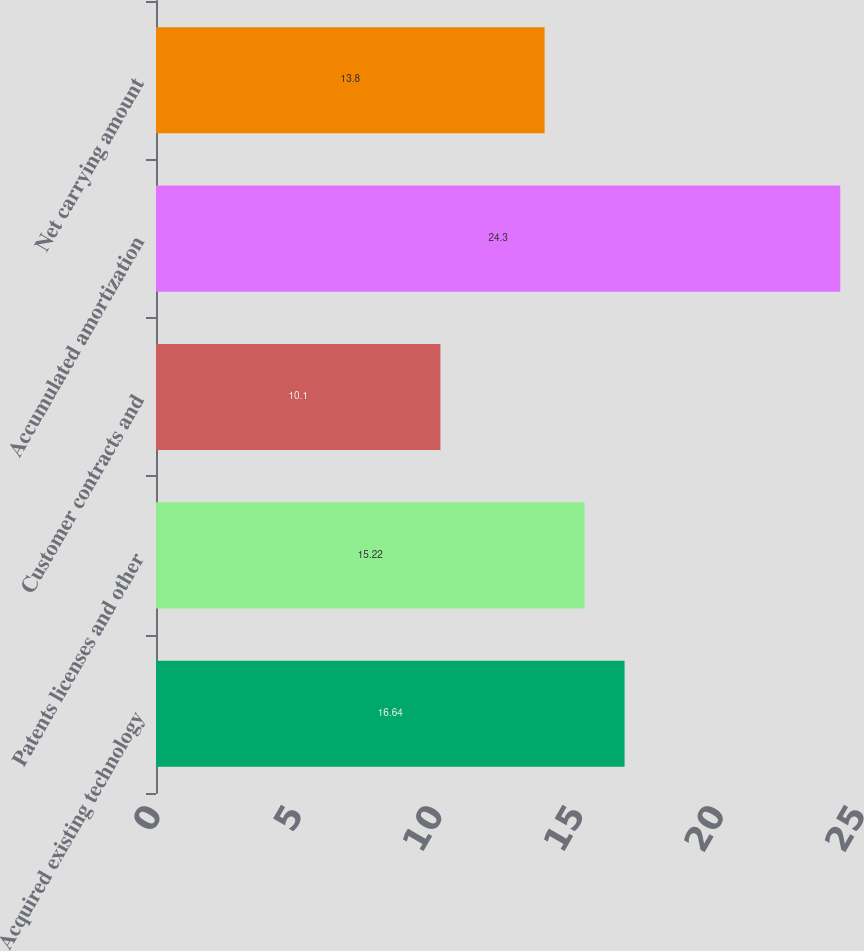<chart> <loc_0><loc_0><loc_500><loc_500><bar_chart><fcel>Acquired existing technology<fcel>Patents licenses and other<fcel>Customer contracts and<fcel>Accumulated amortization<fcel>Net carrying amount<nl><fcel>16.64<fcel>15.22<fcel>10.1<fcel>24.3<fcel>13.8<nl></chart> 